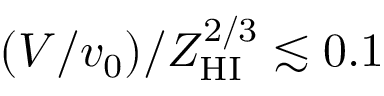<formula> <loc_0><loc_0><loc_500><loc_500>( V / v _ { 0 } ) / Z _ { H I } ^ { 2 / 3 } \lesssim 0 . 1</formula> 